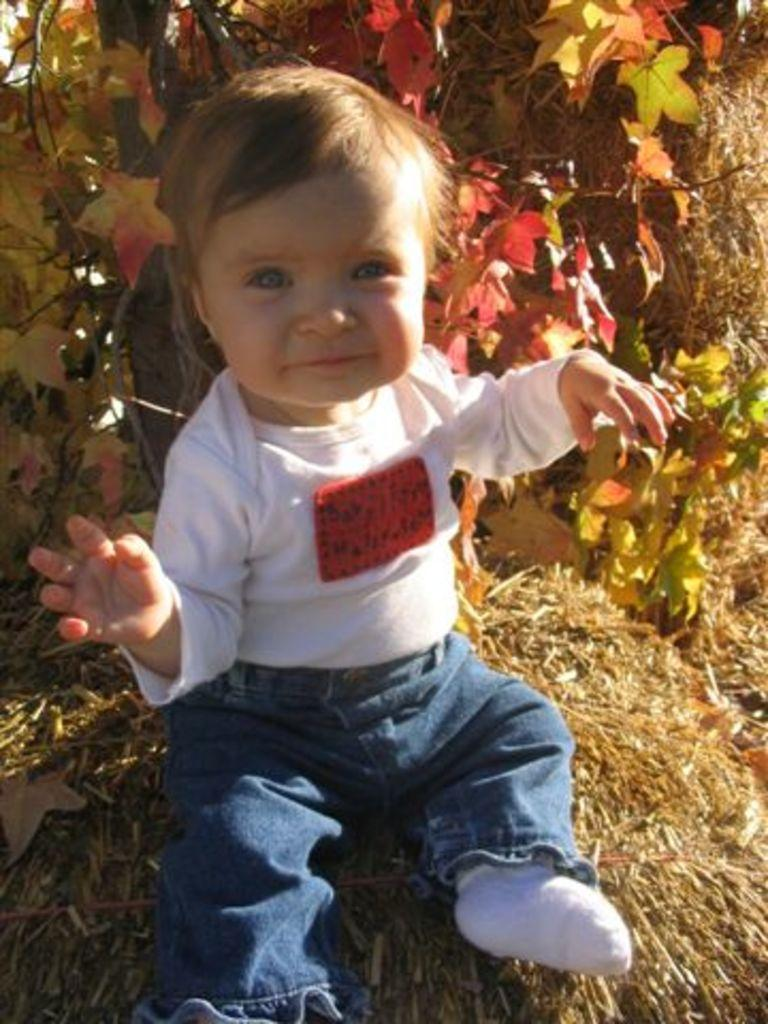What is the main subject of the picture? There is a baby in the picture. What is the baby doing in the picture? The baby is sitting. What can be seen in the background of the picture? There is a tree in the background of the picture. What type of vegetation is visible in the picture? There are leaves visible in the picture. Where is the hall located in the picture? There is no hall present in the picture; it features a baby sitting with a tree in the background. What type of jelly is being used to decorate the leaves in the picture? There is no jelly present in the picture; it only shows a baby sitting and a tree with leaves in the background. 